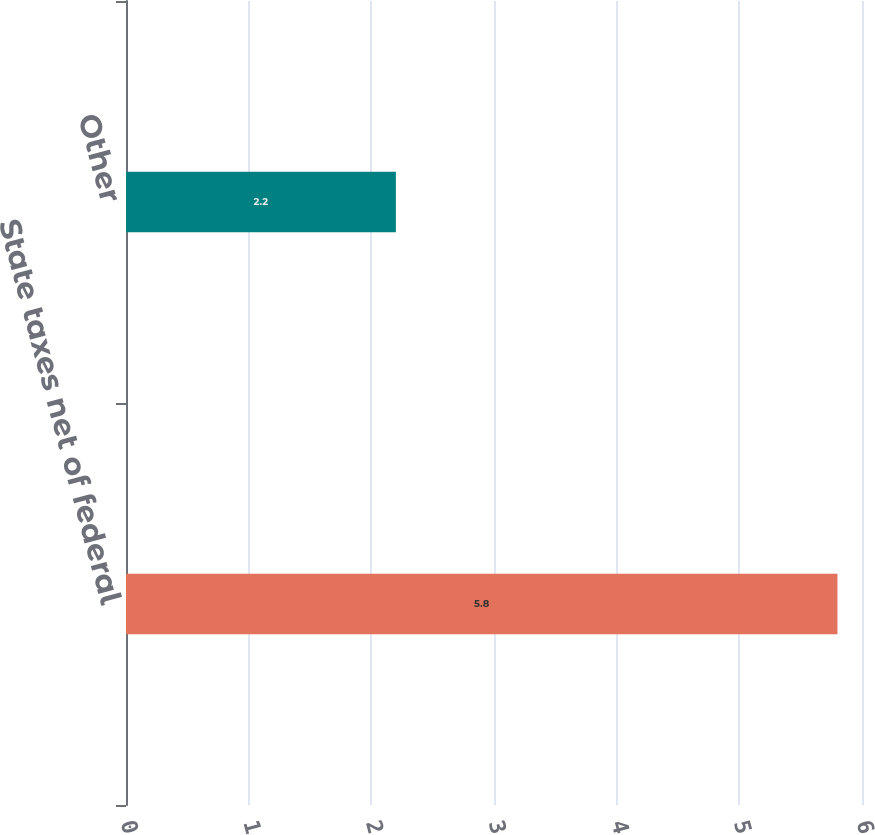Convert chart. <chart><loc_0><loc_0><loc_500><loc_500><bar_chart><fcel>State taxes net of federal<fcel>Other<nl><fcel>5.8<fcel>2.2<nl></chart> 